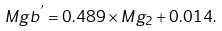<formula> <loc_0><loc_0><loc_500><loc_500>M g { b } ^ { ^ { \prime } } = 0 . 4 8 9 \times M g _ { 2 } + 0 . 0 1 4 .</formula> 